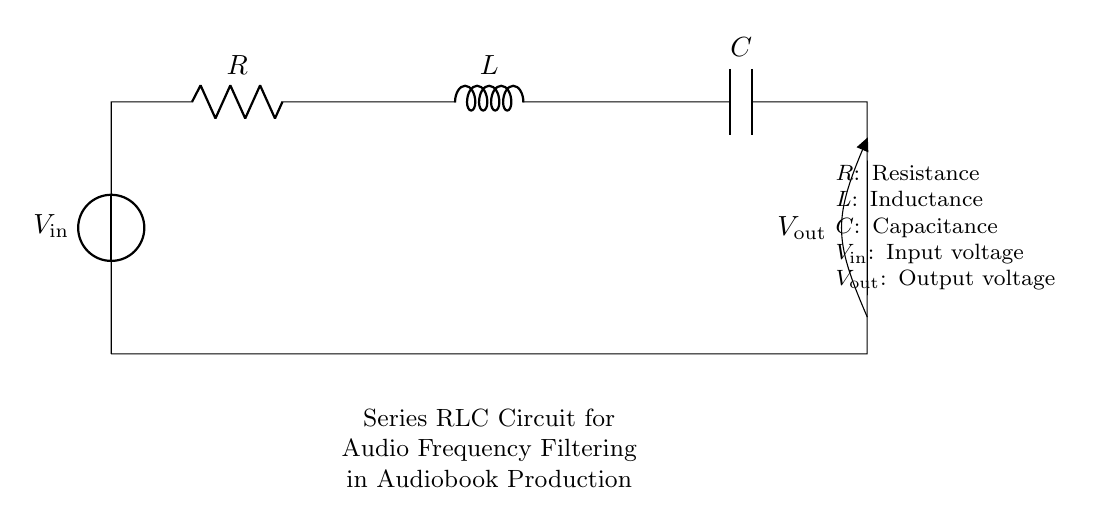What type of circuit is shown? It is a series RLC circuit, which consists of a resistor, inductor, and capacitor connected in series for the purpose of audio frequency filtering.
Answer: Series RLC What is the input voltage in the circuit? The input voltage is labeled as V_in in the diagram, which indicates the source voltage connected to the circuit.
Answer: V_in What components are included in this circuit? The circuit includes three components: a resistor (R), an inductor (L), and a capacitor (C), all connected in series.
Answer: Resistor, Inductor, Capacitor What is the purpose of this circuit in audiobook production? The primary purpose of this circuit is to filter audio frequencies, allowing specific frequency ranges to pass while attenuating others, thus improving sound quality in audiobooks.
Answer: Audio frequency filtering How does the output voltage relate to the input voltage? In a series RLC circuit, the output voltage (V_out) depends on the impedance of the components at different frequencies, meaning it can vary significantly based on the applied frequency of the input voltage.
Answer: It varies with frequency What is the expected effect of increasing the resistance in this circuit? Increasing the resistance will lead to a decrease in the current through the circuit and can affect the bandwidth of the frequency response, potentially leading to a sharper filter effect.
Answer: Decrease in current, sharper filter What happens when the circuit is tuned to resonance? At resonance, the impedance of the circuit is minimized, leading to maximum current flow and a peak in output voltage across the load. This condition allows specific audio frequencies to be amplified most effectively, ideal for audiobook clarity.
Answer: Maximum current flow at resonance 